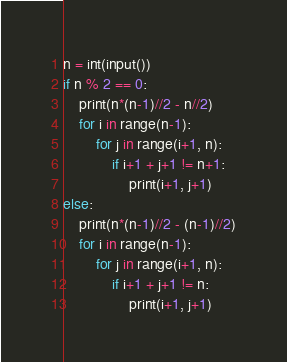Convert code to text. <code><loc_0><loc_0><loc_500><loc_500><_Python_>n = int(input())
if n % 2 == 0:
    print(n*(n-1)//2 - n//2)
    for i in range(n-1):
        for j in range(i+1, n):
            if i+1 + j+1 != n+1:
                print(i+1, j+1)
else:
    print(n*(n-1)//2 - (n-1)//2)
    for i in range(n-1):
        for j in range(i+1, n):
            if i+1 + j+1 != n:
                print(i+1, j+1)
</code> 